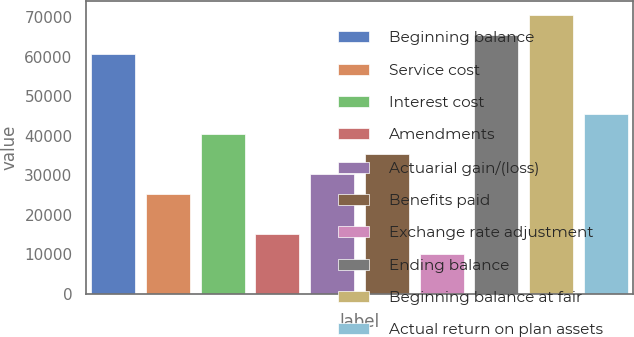<chart> <loc_0><loc_0><loc_500><loc_500><bar_chart><fcel>Beginning balance<fcel>Service cost<fcel>Interest cost<fcel>Amendments<fcel>Actuarial gain/(loss)<fcel>Benefits paid<fcel>Exchange rate adjustment<fcel>Ending balance<fcel>Beginning balance at fair<fcel>Actual return on plan assets<nl><fcel>60524.4<fcel>25225.5<fcel>40353.6<fcel>15140.1<fcel>30268.2<fcel>35310.9<fcel>10097.4<fcel>65567.1<fcel>70609.8<fcel>45396.3<nl></chart> 